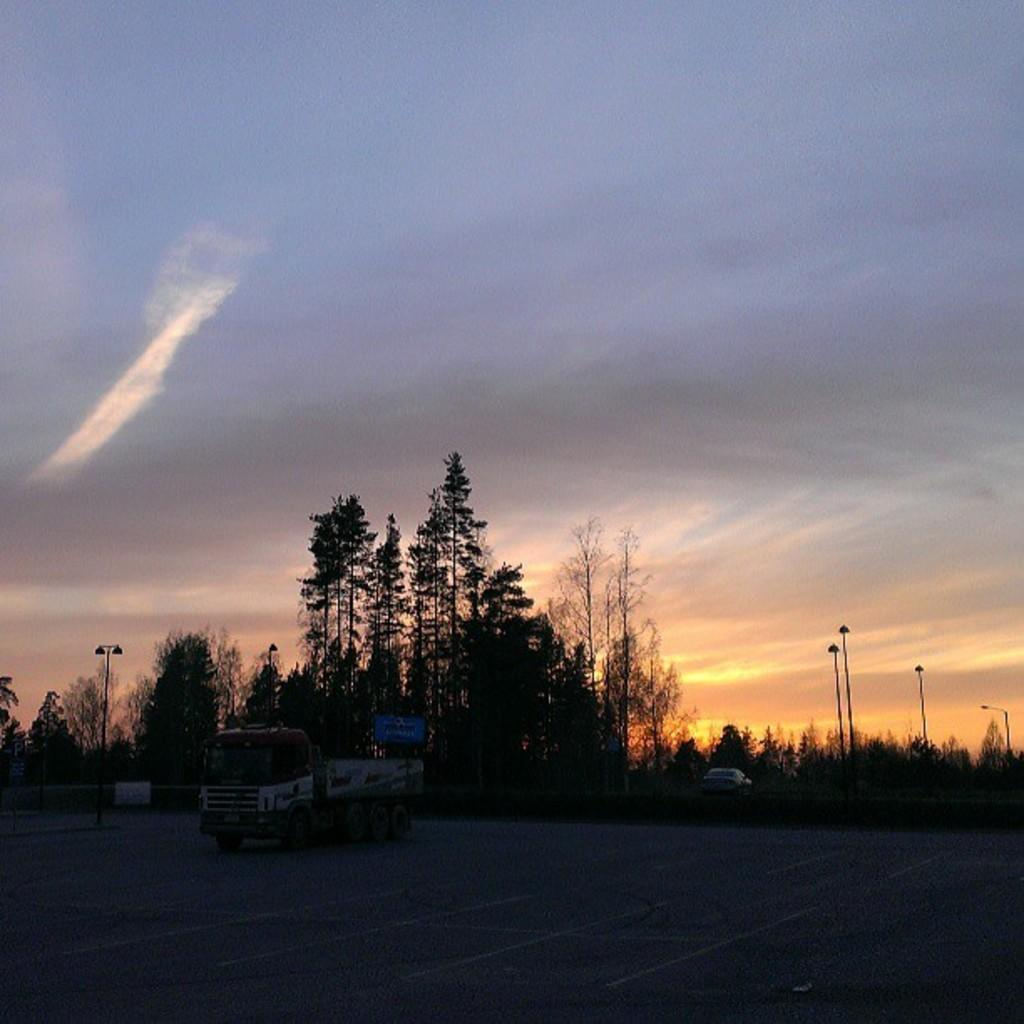What can be seen in the image? There are vehicles in the image. What is visible in the background of the image? There are trees in the background of the image. What is the color of the trees? The trees are green in color. What else can be seen in the image besides the vehicles and trees? There are light poles in the image. How would you describe the sky in the image? The sky is white-gray in color. How many sticks are in the image? There are no sticks present in the image. 